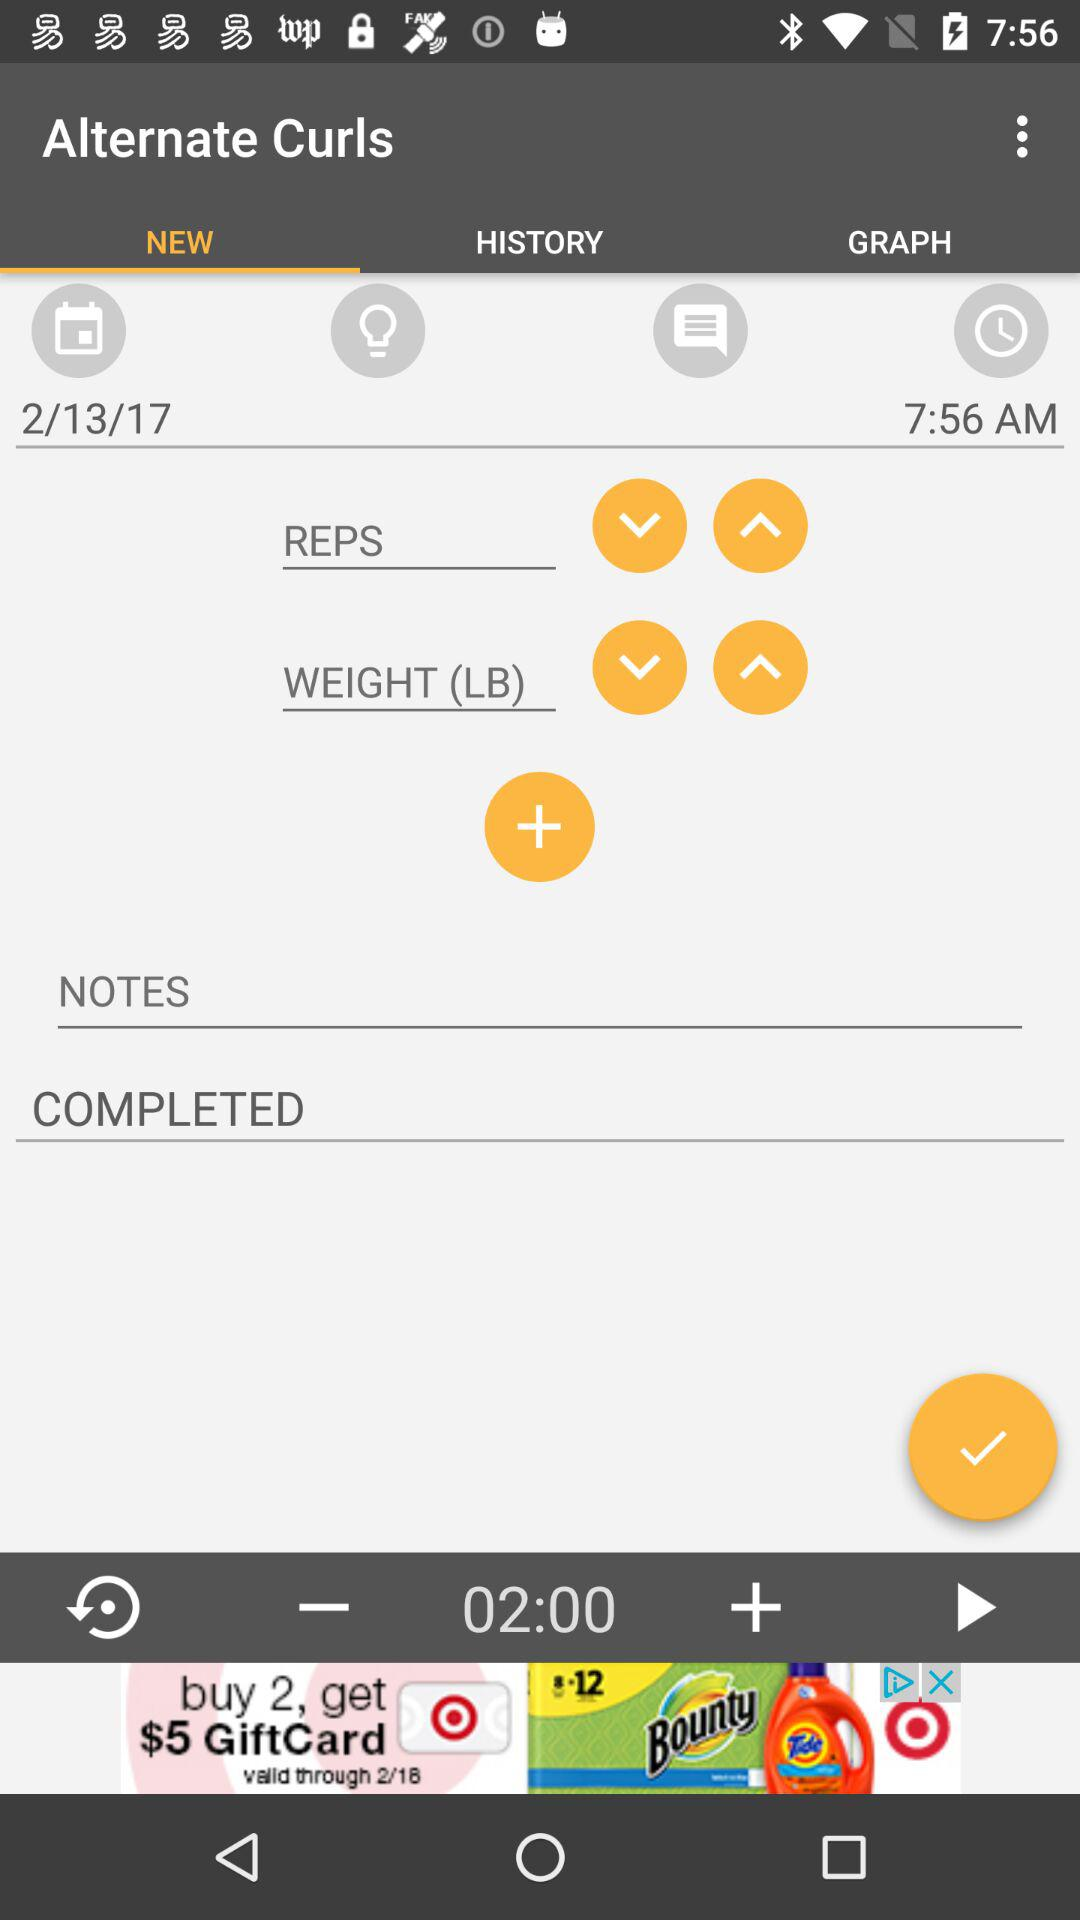Which option is selected in "Alternate Curls"? The option selected in "Alternate Curls" is "NEW". 